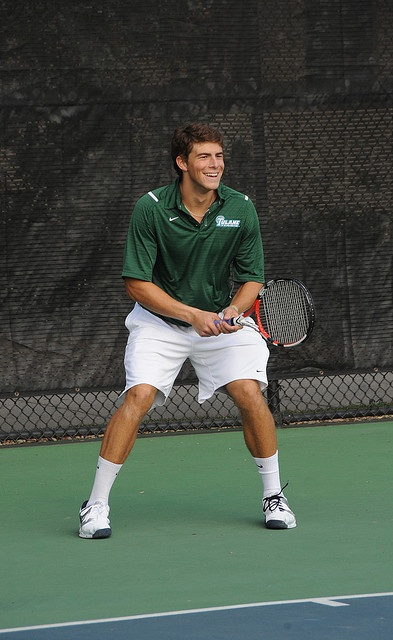Describe the objects in this image and their specific colors. I can see people in black, lightgray, and gray tones and tennis racket in black, gray, darkgray, and lightgray tones in this image. 